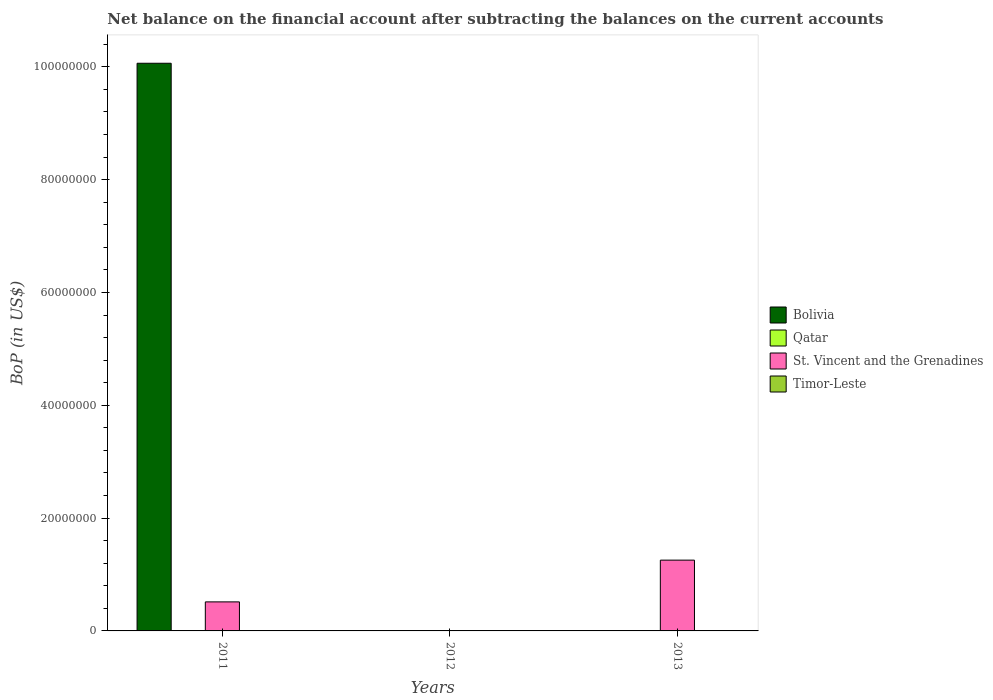How many different coloured bars are there?
Your response must be concise. 2. How many bars are there on the 1st tick from the left?
Offer a very short reply. 2. How many bars are there on the 3rd tick from the right?
Your answer should be compact. 2. What is the label of the 1st group of bars from the left?
Keep it short and to the point. 2011. Across all years, what is the maximum Balance of Payments in St. Vincent and the Grenadines?
Offer a terse response. 1.26e+07. In which year was the Balance of Payments in Bolivia maximum?
Your answer should be very brief. 2011. What is the total Balance of Payments in St. Vincent and the Grenadines in the graph?
Keep it short and to the point. 1.77e+07. What is the difference between the Balance of Payments in St. Vincent and the Grenadines in 2011 and the Balance of Payments in Timor-Leste in 2013?
Your answer should be very brief. 5.15e+06. In the year 2011, what is the difference between the Balance of Payments in St. Vincent and the Grenadines and Balance of Payments in Bolivia?
Offer a terse response. -9.55e+07. In how many years, is the Balance of Payments in Qatar greater than 48000000 US$?
Your response must be concise. 0. What is the ratio of the Balance of Payments in St. Vincent and the Grenadines in 2011 to that in 2013?
Offer a terse response. 0.41. Is it the case that in every year, the sum of the Balance of Payments in Qatar and Balance of Payments in Timor-Leste is greater than the sum of Balance of Payments in Bolivia and Balance of Payments in St. Vincent and the Grenadines?
Offer a very short reply. No. How many years are there in the graph?
Offer a terse response. 3. What is the difference between two consecutive major ticks on the Y-axis?
Make the answer very short. 2.00e+07. Are the values on the major ticks of Y-axis written in scientific E-notation?
Offer a very short reply. No. Does the graph contain grids?
Give a very brief answer. No. How many legend labels are there?
Provide a succinct answer. 4. How are the legend labels stacked?
Your answer should be very brief. Vertical. What is the title of the graph?
Keep it short and to the point. Net balance on the financial account after subtracting the balances on the current accounts. What is the label or title of the X-axis?
Provide a short and direct response. Years. What is the label or title of the Y-axis?
Make the answer very short. BoP (in US$). What is the BoP (in US$) in Bolivia in 2011?
Make the answer very short. 1.01e+08. What is the BoP (in US$) of St. Vincent and the Grenadines in 2011?
Offer a very short reply. 5.15e+06. What is the BoP (in US$) in Timor-Leste in 2011?
Keep it short and to the point. 0. What is the BoP (in US$) of Bolivia in 2012?
Offer a very short reply. 0. What is the BoP (in US$) of Qatar in 2012?
Keep it short and to the point. 0. What is the BoP (in US$) in St. Vincent and the Grenadines in 2012?
Keep it short and to the point. 0. What is the BoP (in US$) of Timor-Leste in 2012?
Your answer should be compact. 0. What is the BoP (in US$) of Bolivia in 2013?
Offer a very short reply. 0. What is the BoP (in US$) in Qatar in 2013?
Your answer should be very brief. 0. What is the BoP (in US$) in St. Vincent and the Grenadines in 2013?
Give a very brief answer. 1.26e+07. Across all years, what is the maximum BoP (in US$) in Bolivia?
Ensure brevity in your answer.  1.01e+08. Across all years, what is the maximum BoP (in US$) in St. Vincent and the Grenadines?
Provide a short and direct response. 1.26e+07. What is the total BoP (in US$) of Bolivia in the graph?
Keep it short and to the point. 1.01e+08. What is the total BoP (in US$) in Qatar in the graph?
Provide a succinct answer. 0. What is the total BoP (in US$) in St. Vincent and the Grenadines in the graph?
Provide a succinct answer. 1.77e+07. What is the total BoP (in US$) in Timor-Leste in the graph?
Ensure brevity in your answer.  0. What is the difference between the BoP (in US$) of St. Vincent and the Grenadines in 2011 and that in 2013?
Keep it short and to the point. -7.40e+06. What is the difference between the BoP (in US$) of Bolivia in 2011 and the BoP (in US$) of St. Vincent and the Grenadines in 2013?
Offer a very short reply. 8.81e+07. What is the average BoP (in US$) in Bolivia per year?
Ensure brevity in your answer.  3.35e+07. What is the average BoP (in US$) of St. Vincent and the Grenadines per year?
Make the answer very short. 5.90e+06. In the year 2011, what is the difference between the BoP (in US$) of Bolivia and BoP (in US$) of St. Vincent and the Grenadines?
Provide a short and direct response. 9.55e+07. What is the ratio of the BoP (in US$) of St. Vincent and the Grenadines in 2011 to that in 2013?
Offer a terse response. 0.41. What is the difference between the highest and the lowest BoP (in US$) of Bolivia?
Offer a very short reply. 1.01e+08. What is the difference between the highest and the lowest BoP (in US$) of St. Vincent and the Grenadines?
Offer a terse response. 1.26e+07. 